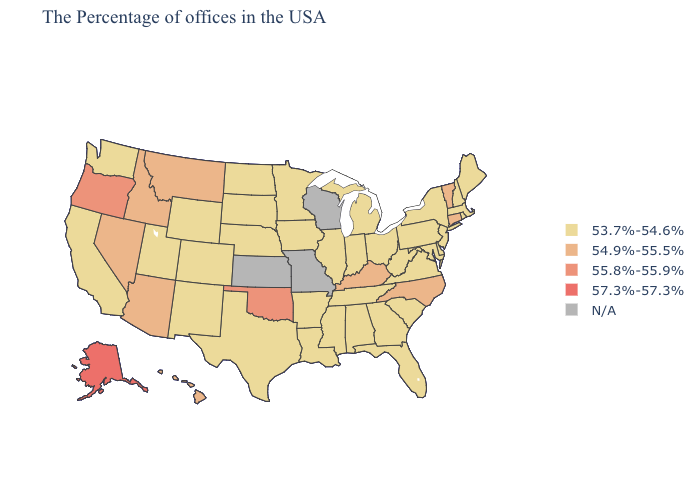What is the highest value in states that border Michigan?
Answer briefly. 53.7%-54.6%. Does Alaska have the highest value in the USA?
Write a very short answer. Yes. What is the highest value in the MidWest ?
Keep it brief. 53.7%-54.6%. Does Maine have the lowest value in the Northeast?
Be succinct. Yes. Does Delaware have the highest value in the USA?
Write a very short answer. No. Name the states that have a value in the range 54.9%-55.5%?
Concise answer only. Vermont, Connecticut, North Carolina, Kentucky, Montana, Arizona, Idaho, Nevada, Hawaii. Among the states that border Oklahoma , which have the highest value?
Concise answer only. Arkansas, Texas, Colorado, New Mexico. Name the states that have a value in the range 54.9%-55.5%?
Quick response, please. Vermont, Connecticut, North Carolina, Kentucky, Montana, Arizona, Idaho, Nevada, Hawaii. Does South Carolina have the lowest value in the South?
Quick response, please. Yes. What is the value of Nebraska?
Keep it brief. 53.7%-54.6%. Name the states that have a value in the range N/A?
Write a very short answer. Wisconsin, Missouri, Kansas. What is the value of Alabama?
Write a very short answer. 53.7%-54.6%. 